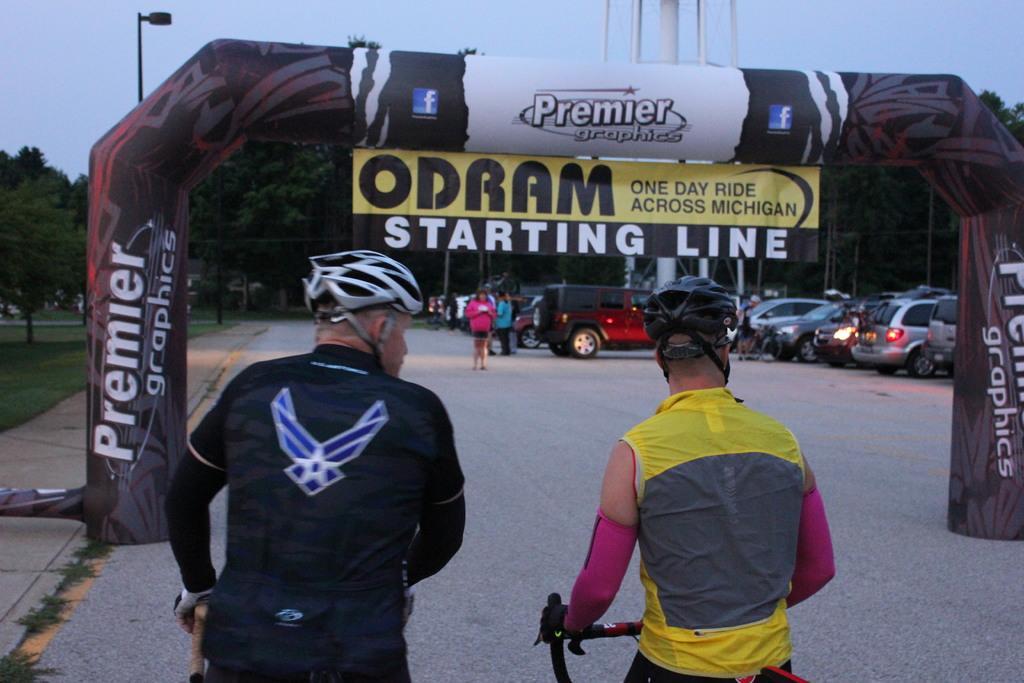How would you summarize this image in a sentence or two? In this picture, there are two members riding a bicycle. Both of them were wearing helmets. There is a balloon entrance here. In the background we can observe some cars parked here and some of them walking. There are some trees, current street light pole and a sky here. 